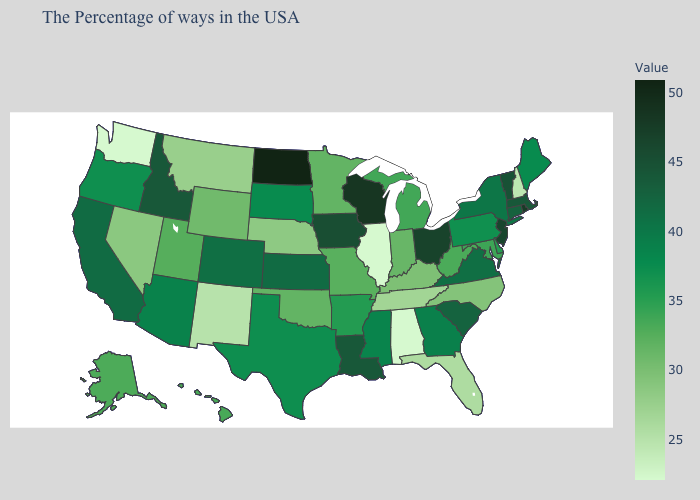Does Vermont have the highest value in the USA?
Answer briefly. No. Which states have the lowest value in the USA?
Quick response, please. Alabama, Illinois, Washington. Is the legend a continuous bar?
Be succinct. Yes. Does Ohio have a higher value than North Dakota?
Quick response, please. No. Does New Jersey have a higher value than North Dakota?
Answer briefly. No. 